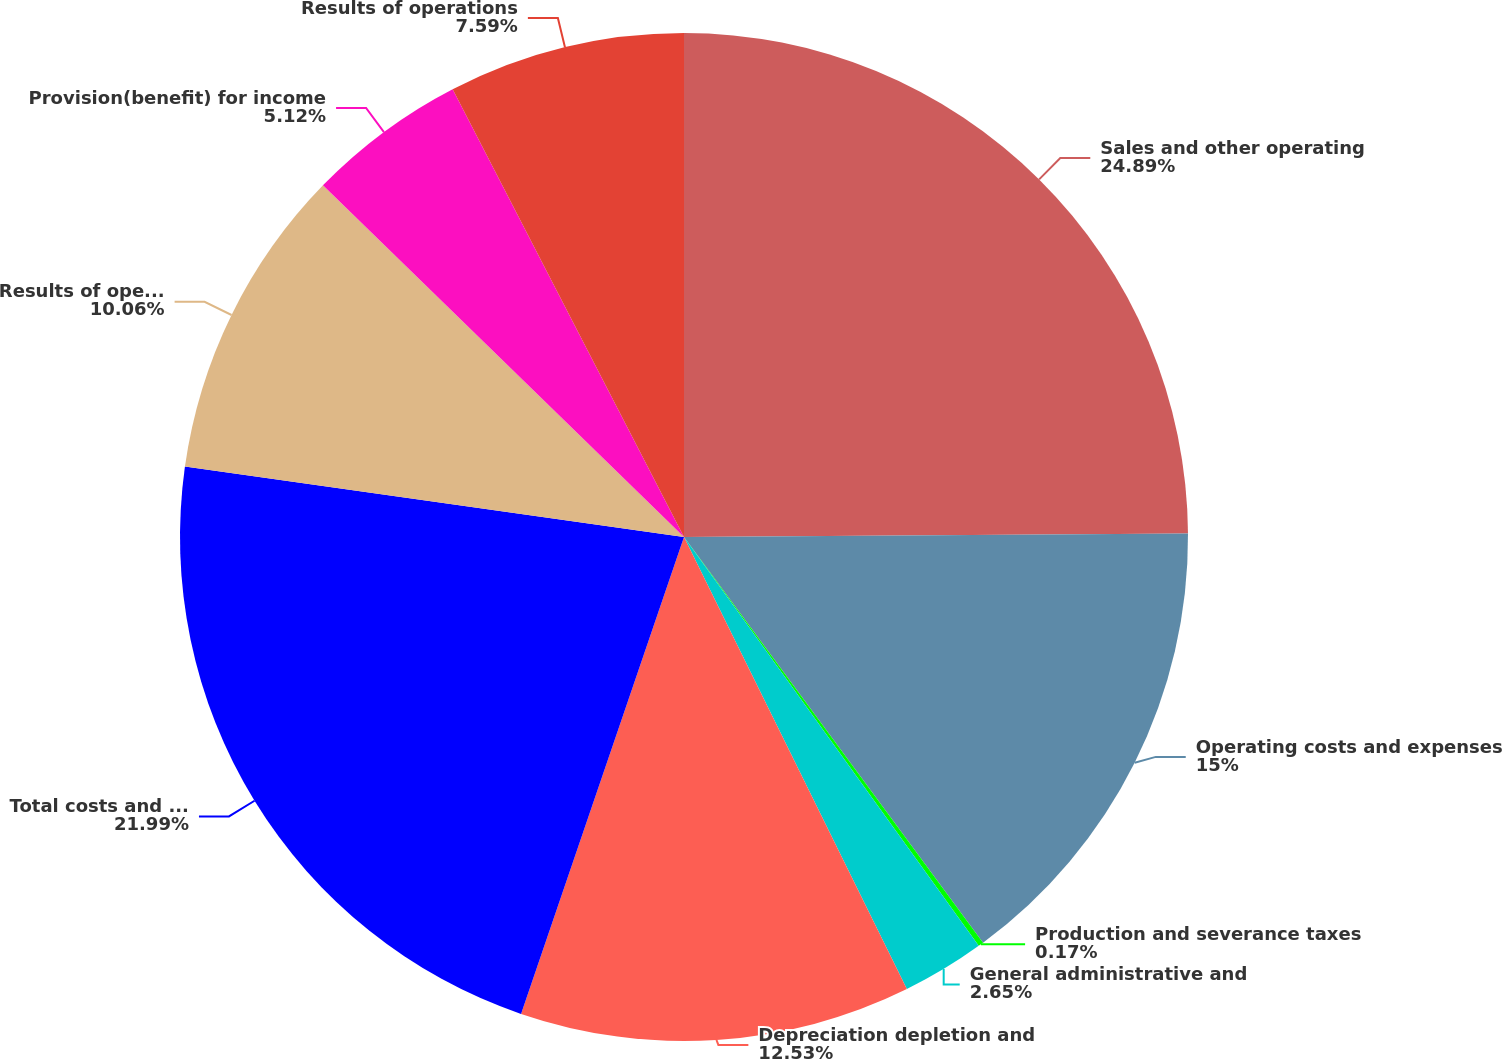<chart> <loc_0><loc_0><loc_500><loc_500><pie_chart><fcel>Sales and other operating<fcel>Operating costs and expenses<fcel>Production and severance taxes<fcel>General administrative and<fcel>Depreciation depletion and<fcel>Total costs and expenses<fcel>Results of operations before<fcel>Provision(benefit) for income<fcel>Results of operations<nl><fcel>24.89%<fcel>15.0%<fcel>0.17%<fcel>2.65%<fcel>12.53%<fcel>21.99%<fcel>10.06%<fcel>5.12%<fcel>7.59%<nl></chart> 